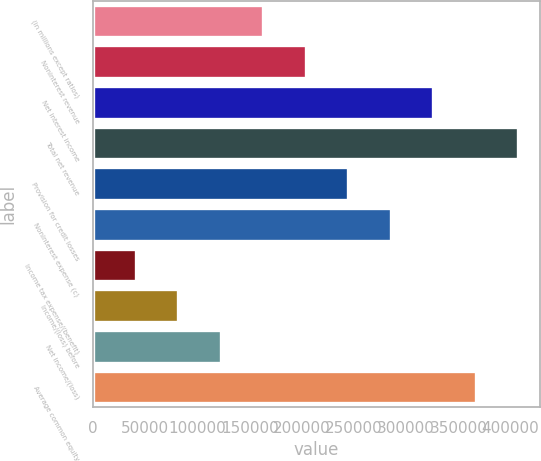<chart> <loc_0><loc_0><loc_500><loc_500><bar_chart><fcel>(in millions except ratios)<fcel>Noninterest revenue<fcel>Net interest income<fcel>Total net revenue<fcel>Provision for credit losses<fcel>Noninterest expense (c)<fcel>Income tax expense/(benefit)<fcel>Income/(loss) before<fcel>Net income/(loss)<fcel>Average common equity<nl><fcel>163029<fcel>203774<fcel>326008<fcel>407497<fcel>244519<fcel>285263<fcel>40795.6<fcel>81540.2<fcel>122285<fcel>366752<nl></chart> 